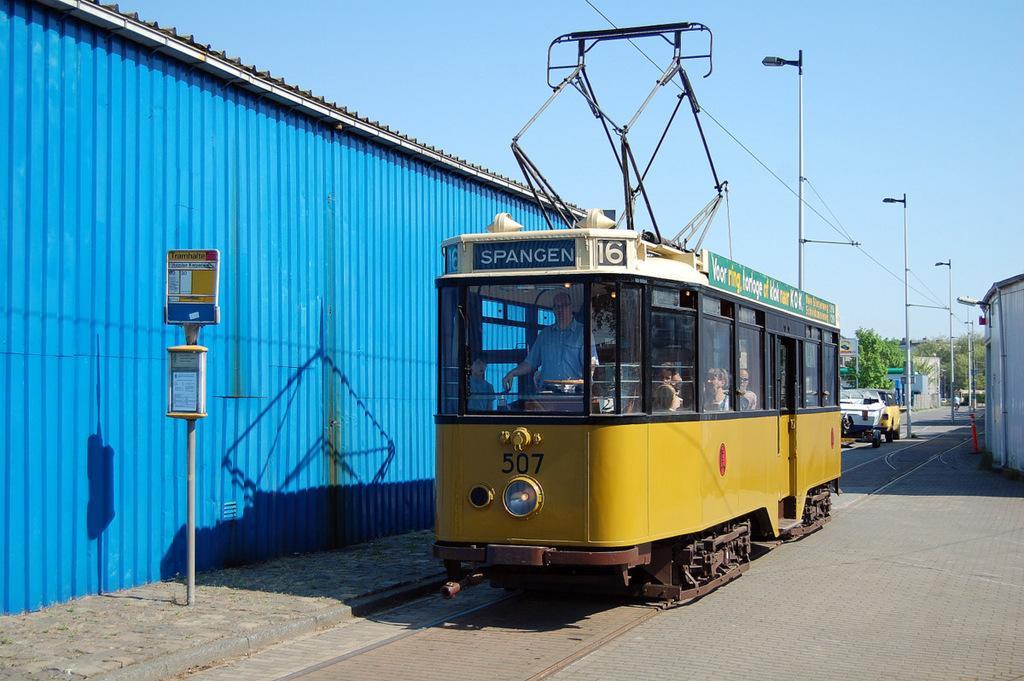Can you describe this image briefly? In this picture I can see a train in the middle, on the left side it looks like a shed and there is a board. On the right side I can see few trees, lamps. At the top there is the sky. 